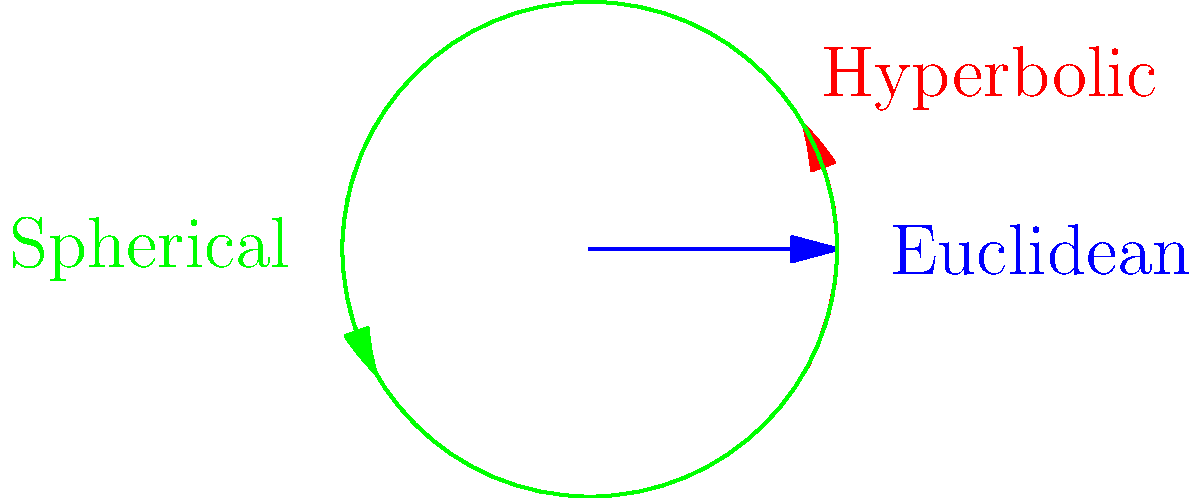In the context of non-Euclidean geometries, which of the depicted light paths would be most relevant for modeling financial market behavior during periods of extreme volatility, and why? To answer this question, let's analyze each geometry and its relevance to financial market behavior:

1. Euclidean geometry (blue line):
   - Represents straight-line motion
   - In finance: Linear relationships, steady-state markets

2. Hyperbolic geometry (red curve):
   - Represents exponential divergence
   - In finance: Rapid market expansions or contractions

3. Spherical geometry (green curve):
   - Represents convergence and cyclical behavior
   - In finance: Mean-reversion, business cycles

During periods of extreme volatility, financial markets often exhibit:
   a) Rapid, exponential changes in prices or returns
   b) Divergence from normal or expected behavior
   c) Non-linear relationships between variables

These characteristics align most closely with hyperbolic geometry, where:
   - Parallel lines diverge exponentially
   - Distance between points increases rapidly
   - Curvature is negative and constant

In financial terms, this could represent:
   - Rapid price movements away from fundamental values
   - Increasing correlation between assets (contagion effects)
   - Amplification of small changes into large market moves

The hyperbolic model captures the non-linear, divergent nature of extreme market behavior better than the linear Euclidean model or the convergent spherical model.
Answer: Hyperbolic geometry (red curve) 